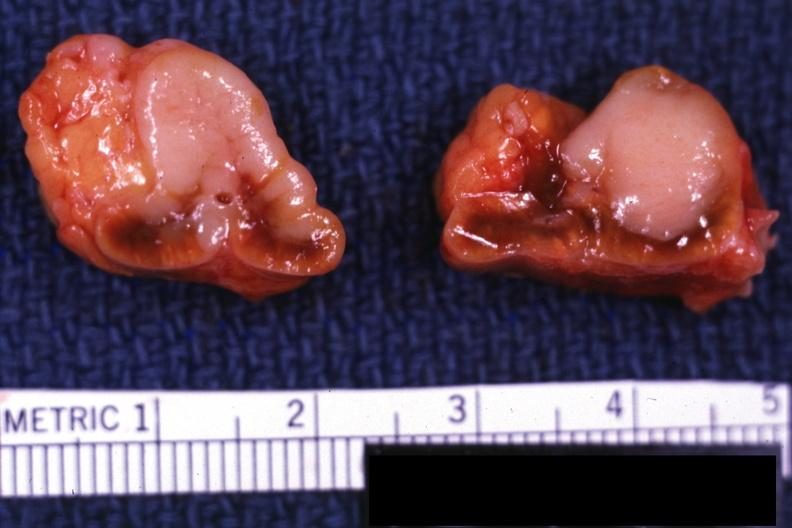s endocrine present?
Answer the question using a single word or phrase. Yes 